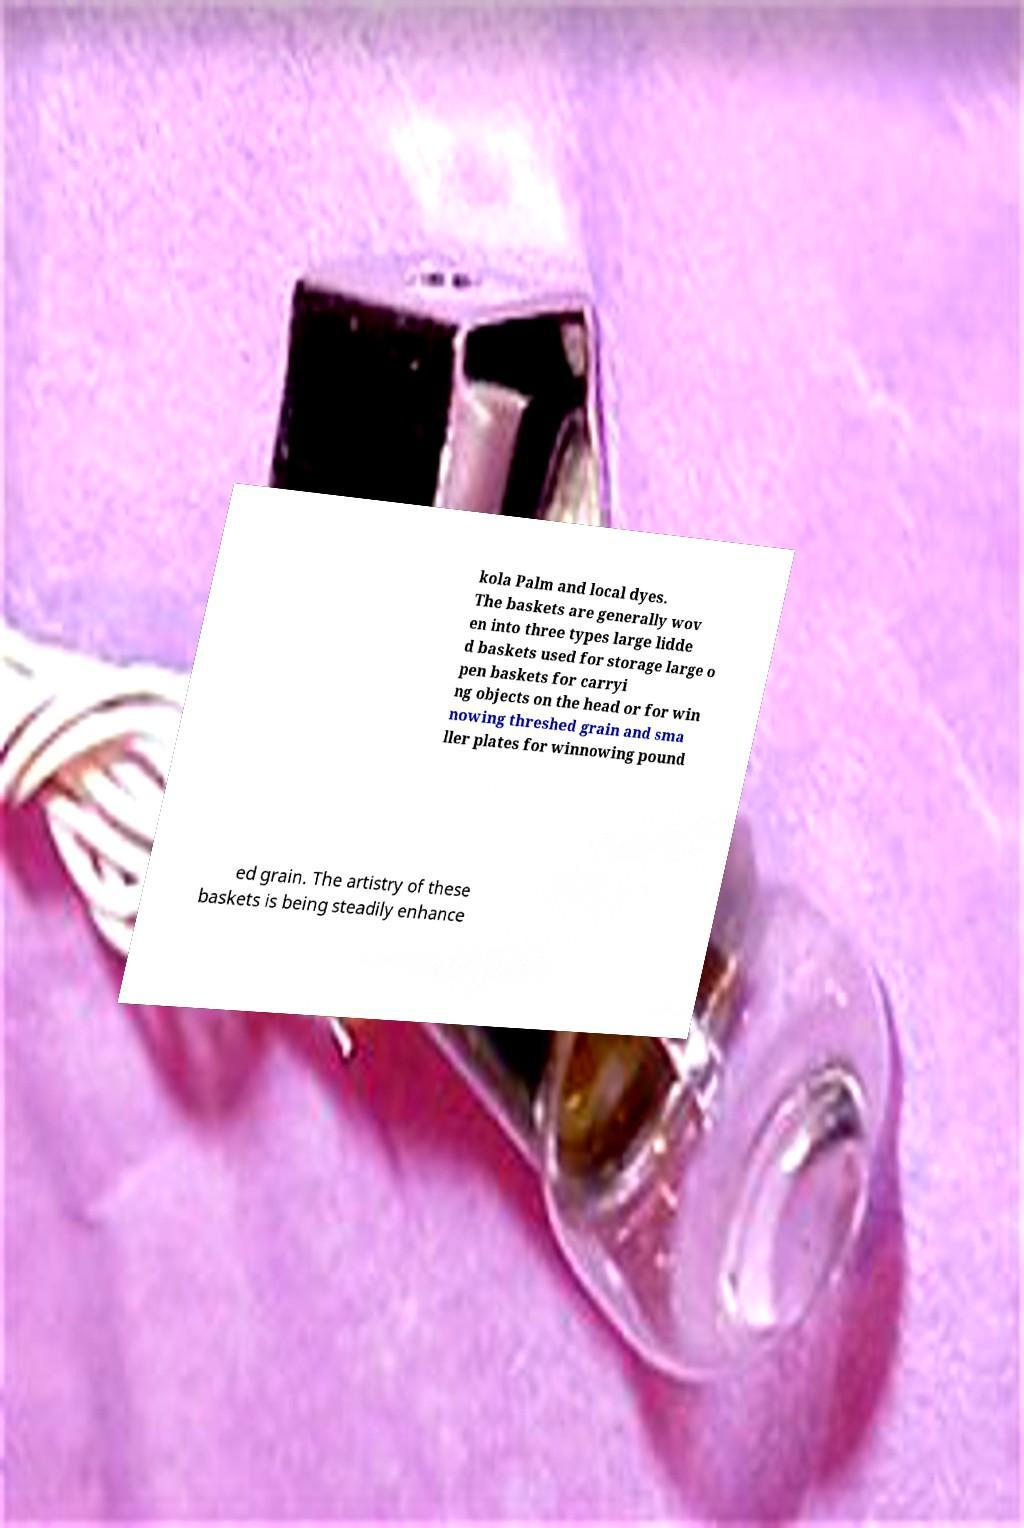Can you accurately transcribe the text from the provided image for me? kola Palm and local dyes. The baskets are generally wov en into three types large lidde d baskets used for storage large o pen baskets for carryi ng objects on the head or for win nowing threshed grain and sma ller plates for winnowing pound ed grain. The artistry of these baskets is being steadily enhance 